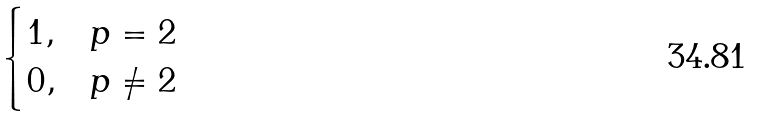Convert formula to latex. <formula><loc_0><loc_0><loc_500><loc_500>\begin{cases} 1 , & p = 2 \\ 0 , & p \neq 2 \end{cases}</formula> 